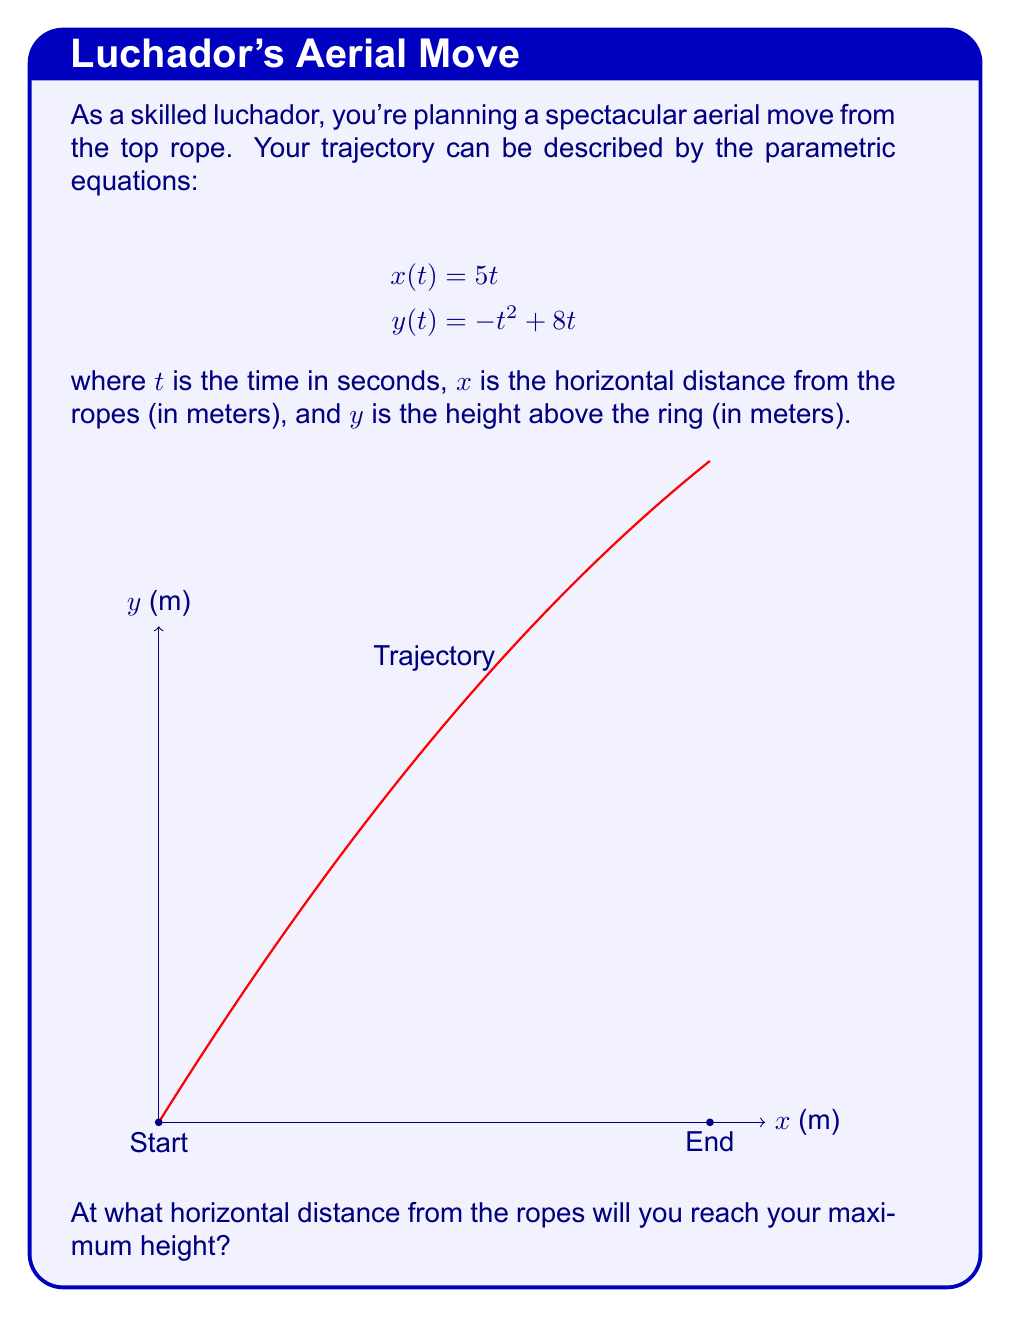Help me with this question. Let's approach this step-by-step:

1) The maximum height occurs when the vertical velocity is zero. In parametric equations, this happens when $\frac{dy}{dt} = 0$.

2) To find $\frac{dy}{dt}$, we differentiate $y(t)$ with respect to $t$:

   $$\frac{dy}{dt} = -2t + 8$$

3) Set this equal to zero and solve for $t$:

   $$-2t + 8 = 0$$
   $$-2t = -8$$
   $$t = 4$$

4) This means you reach your maximum height 4 seconds after jumping.

5) To find the horizontal distance at this time, we substitute $t = 4$ into the equation for $x(t)$:

   $$x(4) = 5(4) = 20$$

Therefore, you will reach your maximum height 20 meters from the ropes.
Answer: 20 meters 